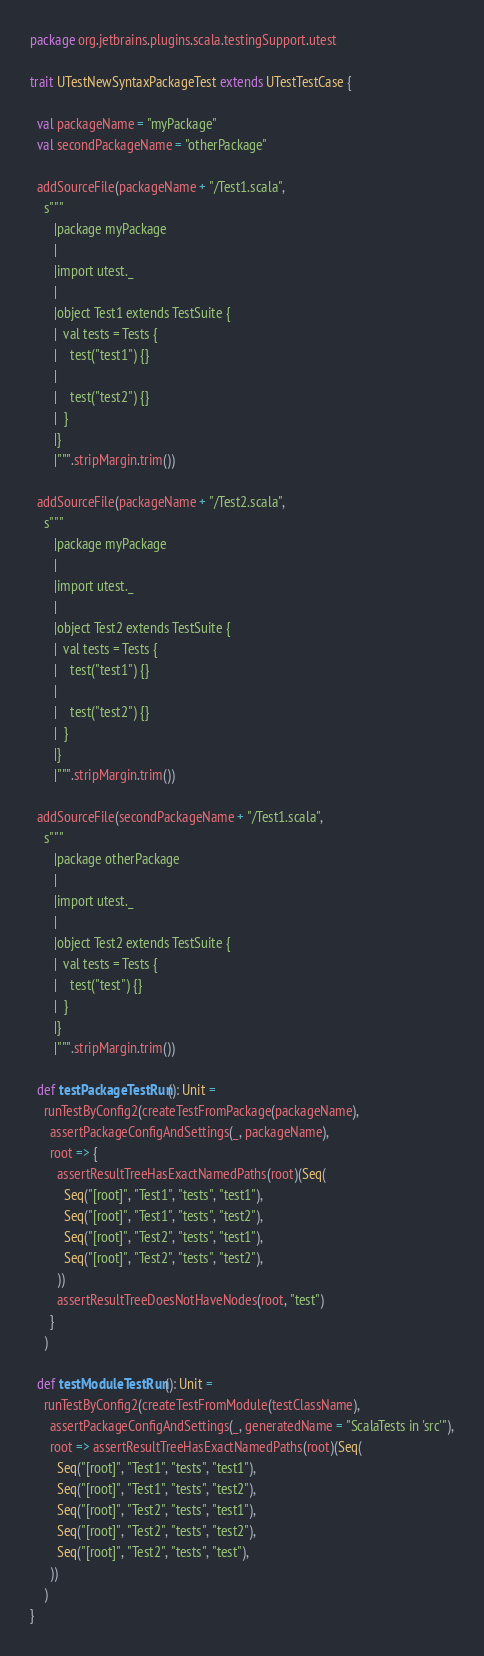<code> <loc_0><loc_0><loc_500><loc_500><_Scala_>package org.jetbrains.plugins.scala.testingSupport.utest

trait UTestNewSyntaxPackageTest extends UTestTestCase {

  val packageName = "myPackage"
  val secondPackageName = "otherPackage"

  addSourceFile(packageName + "/Test1.scala",
    s"""
       |package myPackage
       |
       |import utest._
       |
       |object Test1 extends TestSuite {
       |  val tests = Tests {
       |    test("test1") {}
       |
       |    test("test2") {}
       |  }
       |}
       |""".stripMargin.trim())

  addSourceFile(packageName + "/Test2.scala",
    s"""
       |package myPackage
       |
       |import utest._
       |
       |object Test2 extends TestSuite {
       |  val tests = Tests {
       |    test("test1") {}
       |
       |    test("test2") {}
       |  }
       |}
       |""".stripMargin.trim())

  addSourceFile(secondPackageName + "/Test1.scala",
    s"""
       |package otherPackage
       |
       |import utest._
       |
       |object Test2 extends TestSuite {
       |  val tests = Tests {
       |    test("test") {}
       |  }
       |}
       |""".stripMargin.trim())

  def testPackageTestRun(): Unit =
    runTestByConfig2(createTestFromPackage(packageName),
      assertPackageConfigAndSettings(_, packageName),
      root => {
        assertResultTreeHasExactNamedPaths(root)(Seq(
          Seq("[root]", "Test1", "tests", "test1"),
          Seq("[root]", "Test1", "tests", "test2"),
          Seq("[root]", "Test2", "tests", "test1"),
          Seq("[root]", "Test2", "tests", "test2"),
        ))
        assertResultTreeDoesNotHaveNodes(root, "test")
      }
    )

  def testModuleTestRun(): Unit =
    runTestByConfig2(createTestFromModule(testClassName),
      assertPackageConfigAndSettings(_, generatedName = "ScalaTests in 'src'"),
      root => assertResultTreeHasExactNamedPaths(root)(Seq(
        Seq("[root]", "Test1", "tests", "test1"),
        Seq("[root]", "Test1", "tests", "test2"),
        Seq("[root]", "Test2", "tests", "test1"),
        Seq("[root]", "Test2", "tests", "test2"),
        Seq("[root]", "Test2", "tests", "test"),
      ))
    )
}
</code> 